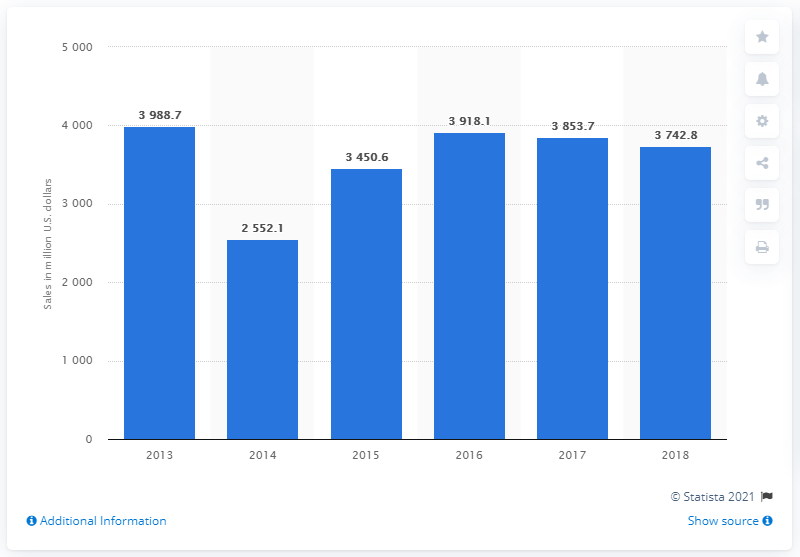Mention a couple of crucial points in this snapshot. Signet Jewelers' net sales of diamonds and diamond jewelry ended in 2018. 